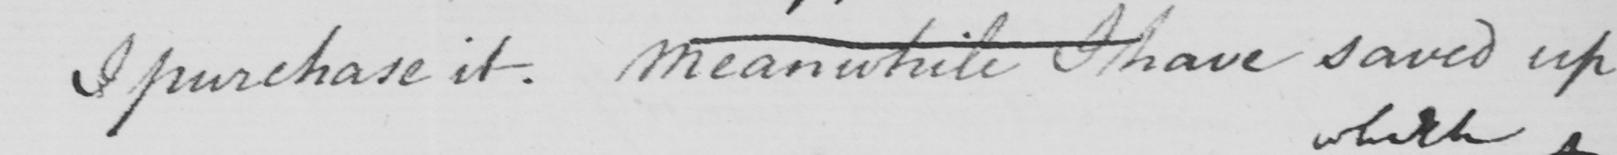Transcribe the text shown in this historical manuscript line. I purchase it . Meanwhile I have saved up 